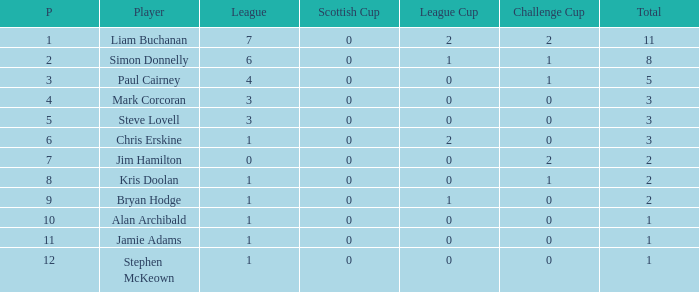What is Kris doolan's league number? 1.0. 